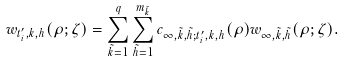<formula> <loc_0><loc_0><loc_500><loc_500>w _ { t ^ { \prime } _ { i } , k , h } ( \rho ; \zeta ) = \sum _ { \tilde { k } = 1 } ^ { q } \sum _ { \tilde { h } = 1 } ^ { m _ { \tilde { k } } } c _ { \infty , \tilde { k } , \tilde { h } ; t ^ { \prime } _ { i } , k , h } ( \rho ) w _ { \infty , \tilde { k } , \tilde { h } } ( \rho ; \zeta ) .</formula> 